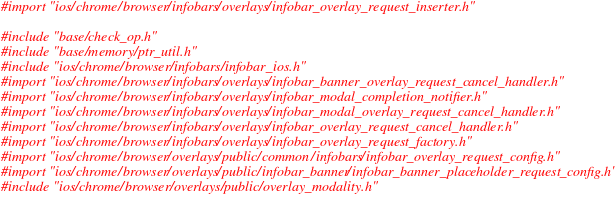Convert code to text. <code><loc_0><loc_0><loc_500><loc_500><_ObjectiveC_>
#import "ios/chrome/browser/infobars/overlays/infobar_overlay_request_inserter.h"

#include "base/check_op.h"
#include "base/memory/ptr_util.h"
#include "ios/chrome/browser/infobars/infobar_ios.h"
#import "ios/chrome/browser/infobars/overlays/infobar_banner_overlay_request_cancel_handler.h"
#import "ios/chrome/browser/infobars/overlays/infobar_modal_completion_notifier.h"
#import "ios/chrome/browser/infobars/overlays/infobar_modal_overlay_request_cancel_handler.h"
#import "ios/chrome/browser/infobars/overlays/infobar_overlay_request_cancel_handler.h"
#import "ios/chrome/browser/infobars/overlays/infobar_overlay_request_factory.h"
#import "ios/chrome/browser/overlays/public/common/infobars/infobar_overlay_request_config.h"
#import "ios/chrome/browser/overlays/public/infobar_banner/infobar_banner_placeholder_request_config.h"
#include "ios/chrome/browser/overlays/public/overlay_modality.h"</code> 